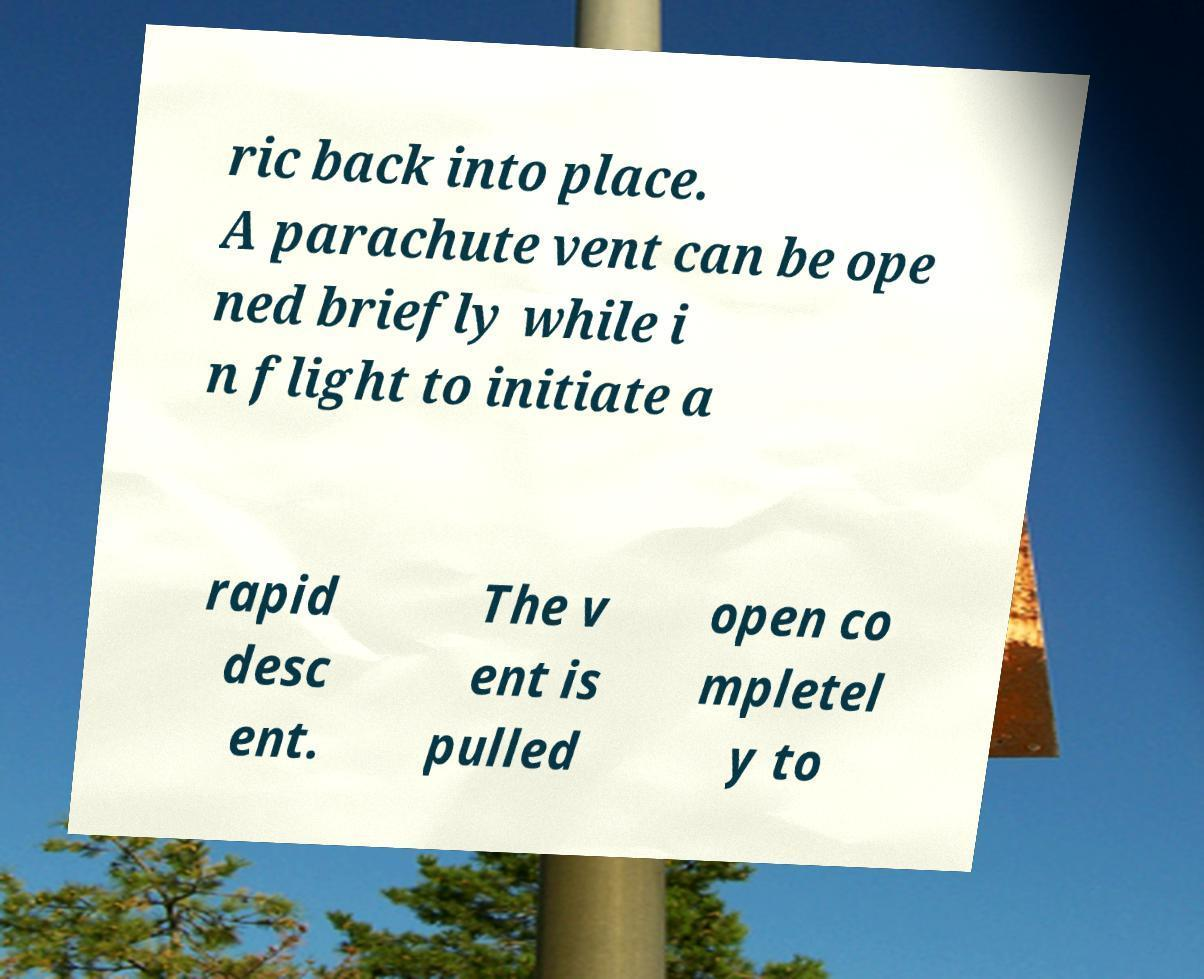There's text embedded in this image that I need extracted. Can you transcribe it verbatim? ric back into place. A parachute vent can be ope ned briefly while i n flight to initiate a rapid desc ent. The v ent is pulled open co mpletel y to 